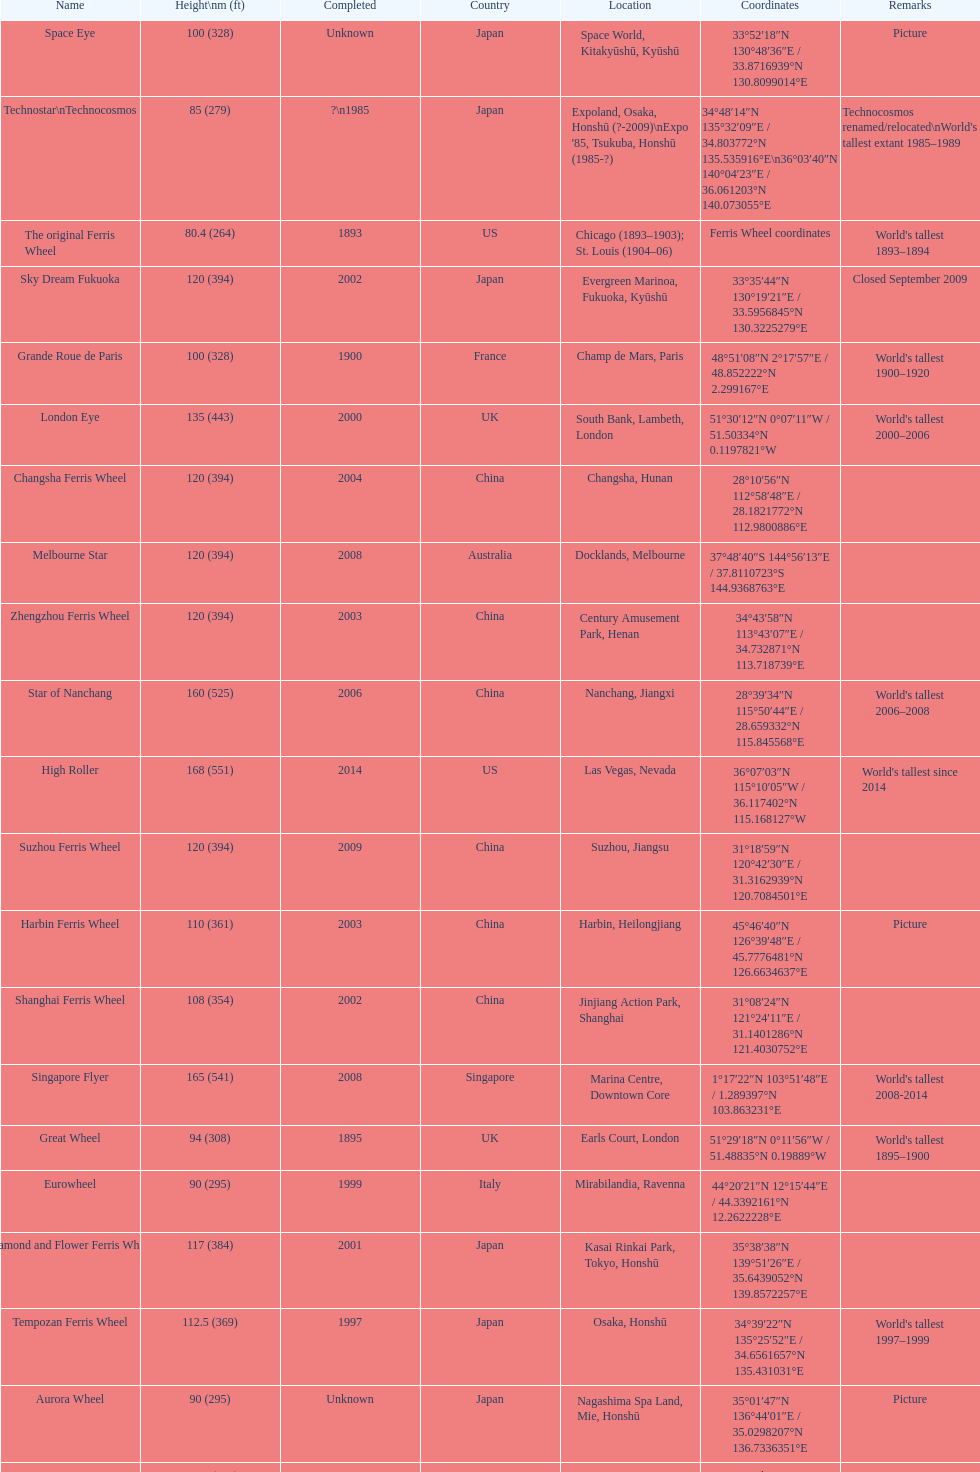Which of the following roller coasters is the oldest: star of lake tai, star of nanchang, melbourne star Star of Nanchang. 